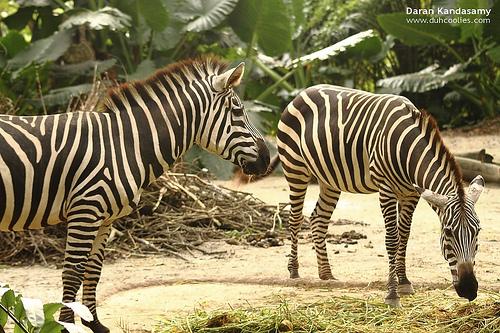Is one of the zebras grazing?
Give a very brief answer. Yes. How many animals?
Short answer required. 2. What animal is this?
Answer briefly. Zebra. 